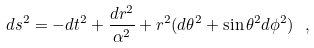<formula> <loc_0><loc_0><loc_500><loc_500>d s ^ { 2 } = - d t ^ { 2 } + \frac { d r ^ { 2 } } { \alpha ^ { 2 } } + r ^ { 2 } ( d \theta ^ { 2 } + \sin \theta ^ { 2 } d \phi ^ { 2 } ) \ ,</formula> 